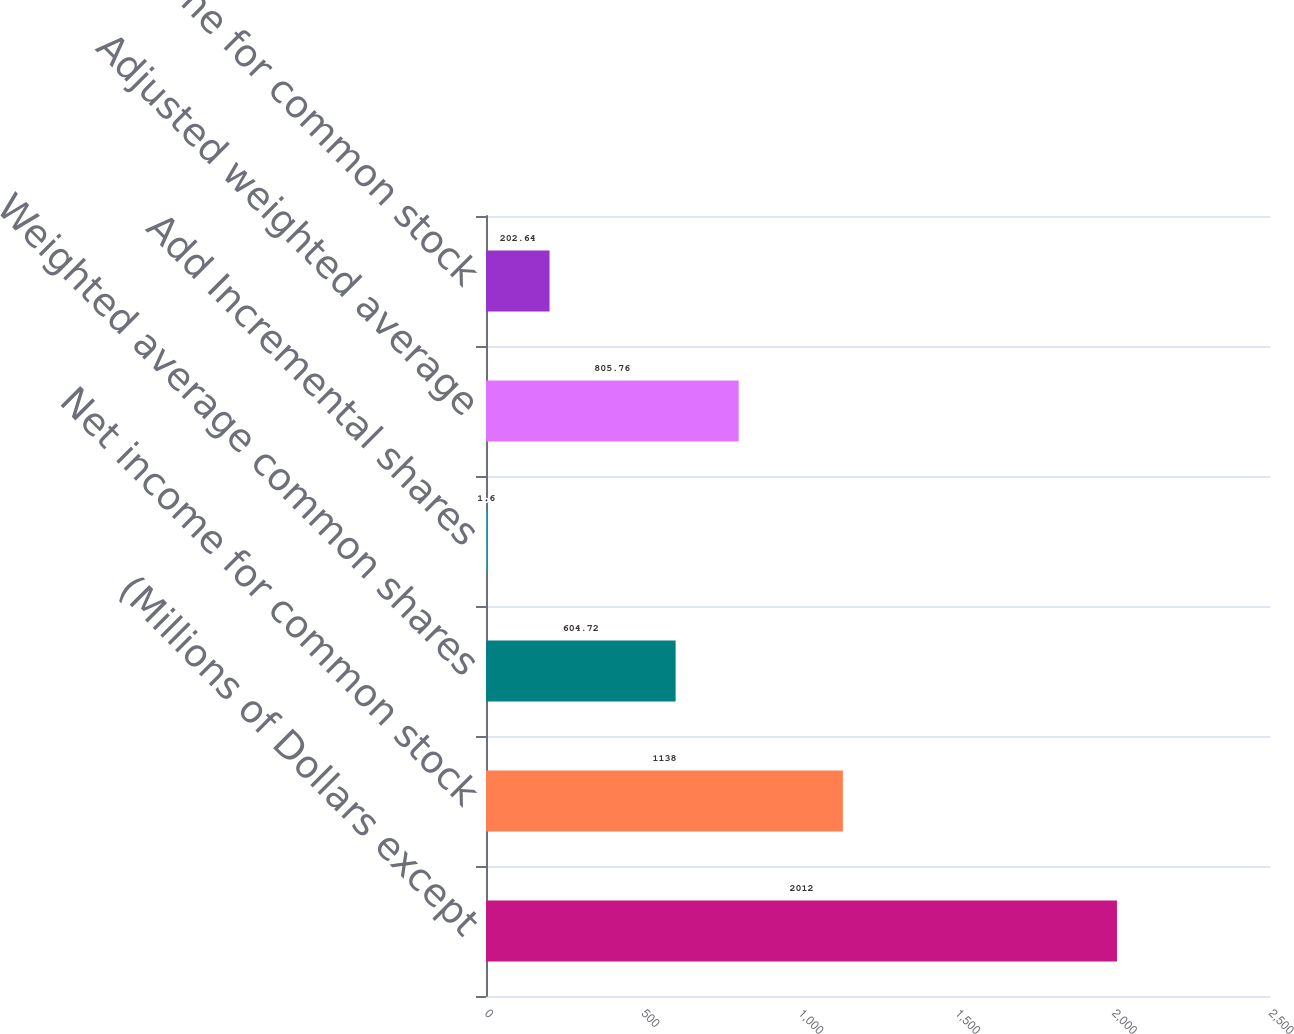<chart> <loc_0><loc_0><loc_500><loc_500><bar_chart><fcel>(Millions of Dollars except<fcel>Net income for common stock<fcel>Weighted average common shares<fcel>Add Incremental shares<fcel>Adjusted weighted average<fcel>Net Income for common stock<nl><fcel>2012<fcel>1138<fcel>604.72<fcel>1.6<fcel>805.76<fcel>202.64<nl></chart> 